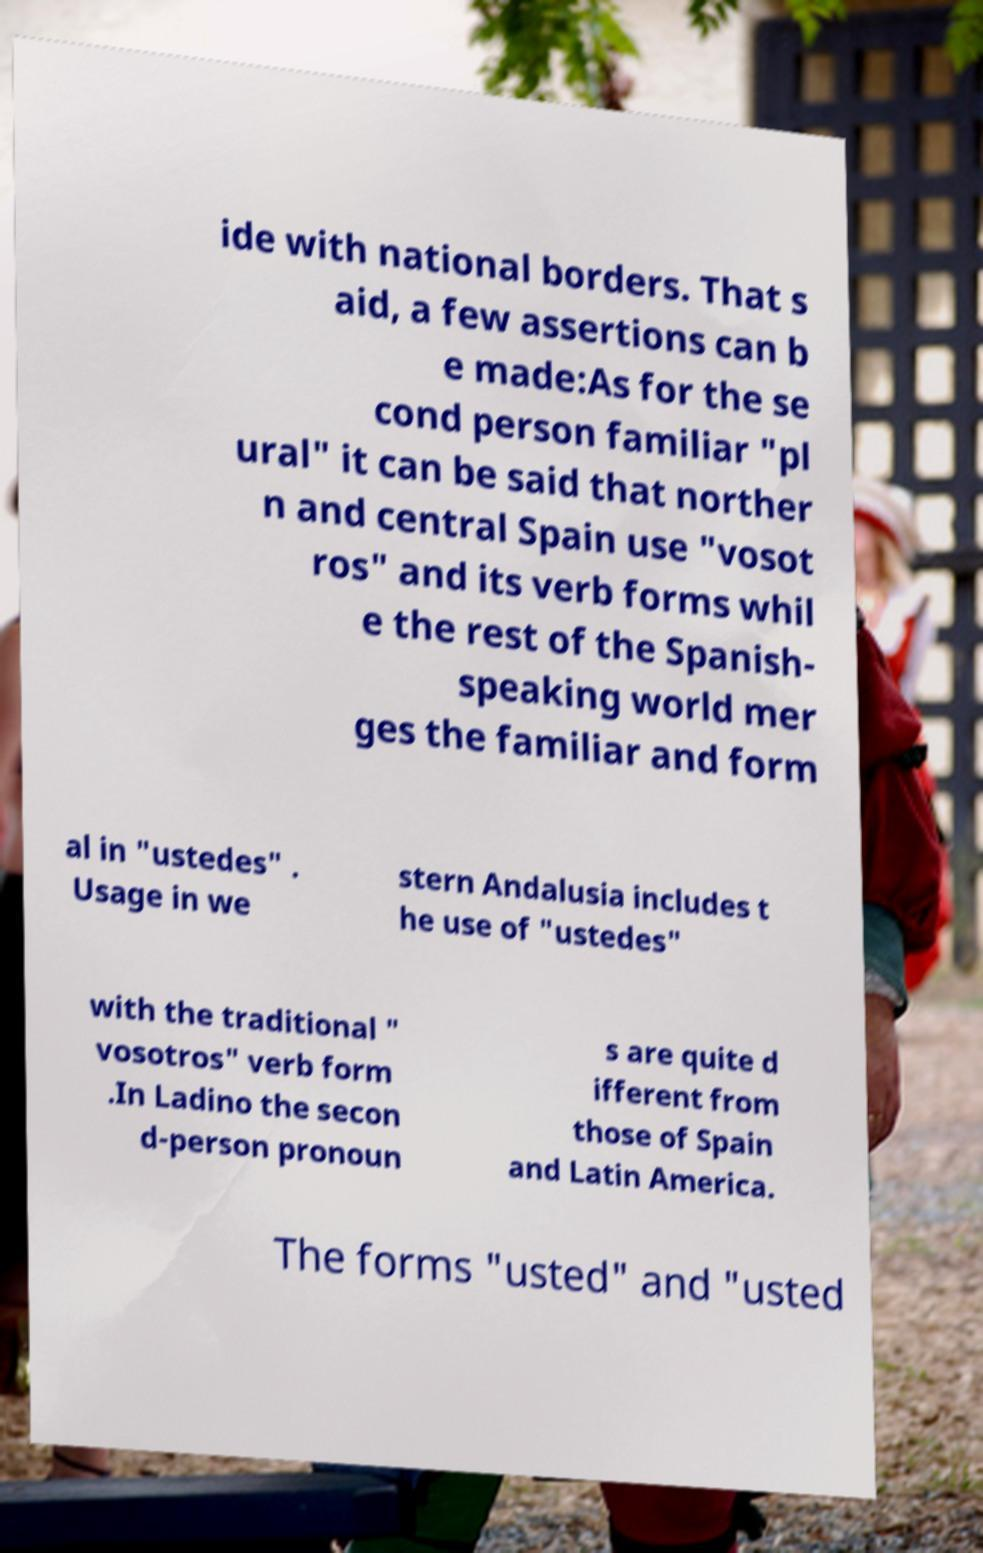What messages or text are displayed in this image? I need them in a readable, typed format. ide with national borders. That s aid, a few assertions can b e made:As for the se cond person familiar "pl ural" it can be said that norther n and central Spain use "vosot ros" and its verb forms whil e the rest of the Spanish- speaking world mer ges the familiar and form al in "ustedes" . Usage in we stern Andalusia includes t he use of "ustedes" with the traditional " vosotros" verb form .In Ladino the secon d-person pronoun s are quite d ifferent from those of Spain and Latin America. The forms "usted" and "usted 